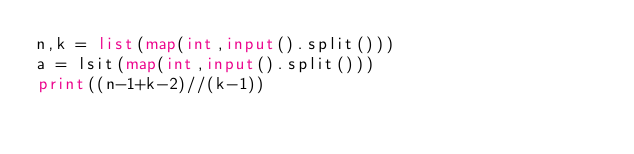Convert code to text. <code><loc_0><loc_0><loc_500><loc_500><_Python_>n,k = list(map(int,input().split()))
a = lsit(map(int,input().split()))
print((n-1+k-2)//(k-1))</code> 